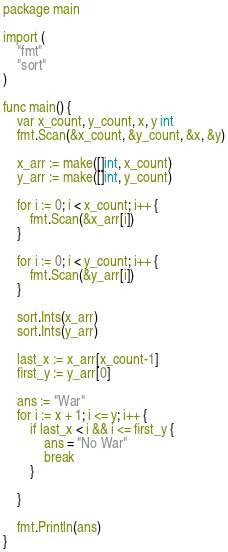<code> <loc_0><loc_0><loc_500><loc_500><_Go_>package main

import (
	"fmt"
	"sort"
)

func main() {
	var x_count, y_count, x, y int
	fmt.Scan(&x_count, &y_count, &x, &y)

	x_arr := make([]int, x_count)
	y_arr := make([]int, y_count)

	for i := 0; i < x_count; i++ {
		fmt.Scan(&x_arr[i])
	}

	for i := 0; i < y_count; i++ {
		fmt.Scan(&y_arr[i])
	}

	sort.Ints(x_arr)
	sort.Ints(y_arr)

	last_x := x_arr[x_count-1]
	first_y := y_arr[0]

	ans := "War"
	for i := x + 1; i <= y; i++ {
		if last_x < i && i <= first_y {
			ans = "No War"
			break
		}

	}

	fmt.Println(ans)
}
</code> 